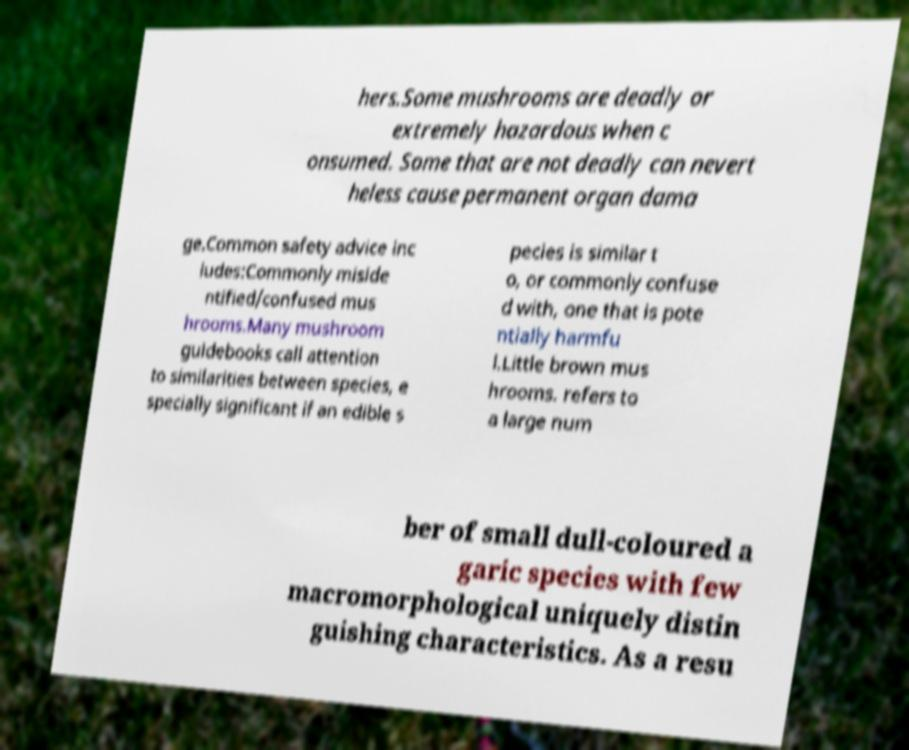Please read and relay the text visible in this image. What does it say? hers.Some mushrooms are deadly or extremely hazardous when c onsumed. Some that are not deadly can nevert heless cause permanent organ dama ge.Common safety advice inc ludes:Commonly miside ntified/confused mus hrooms.Many mushroom guidebooks call attention to similarities between species, e specially significant if an edible s pecies is similar t o, or commonly confuse d with, one that is pote ntially harmfu l.Little brown mus hrooms. refers to a large num ber of small dull-coloured a garic species with few macromorphological uniquely distin guishing characteristics. As a resu 